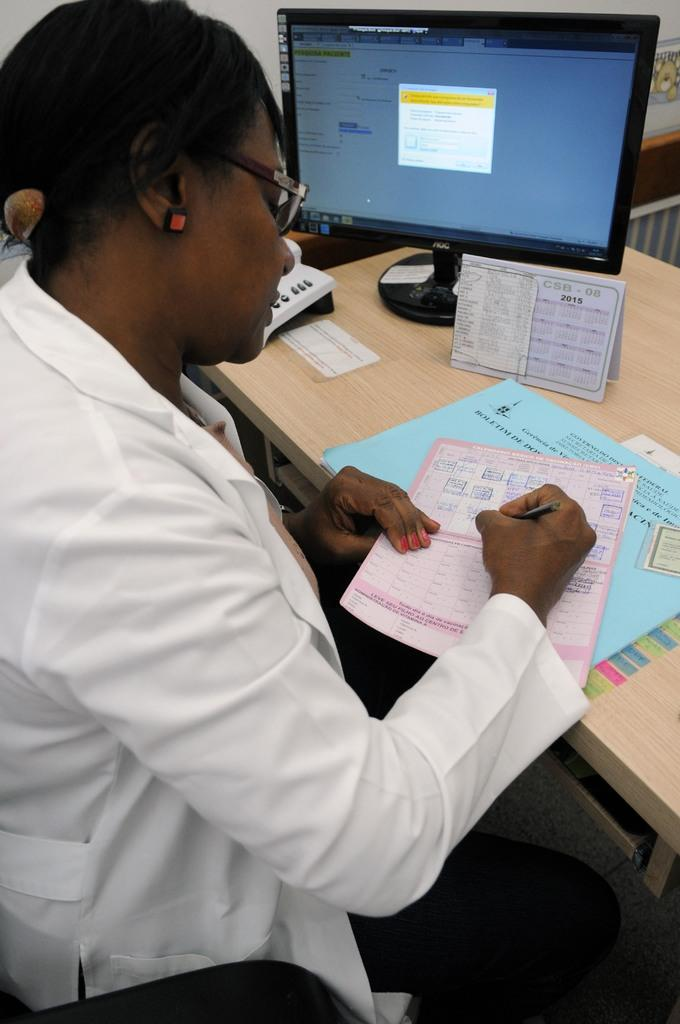<image>
Summarize the visual content of the image. a man writing at a desk  next to a blue paper that says 'boletim' on it 